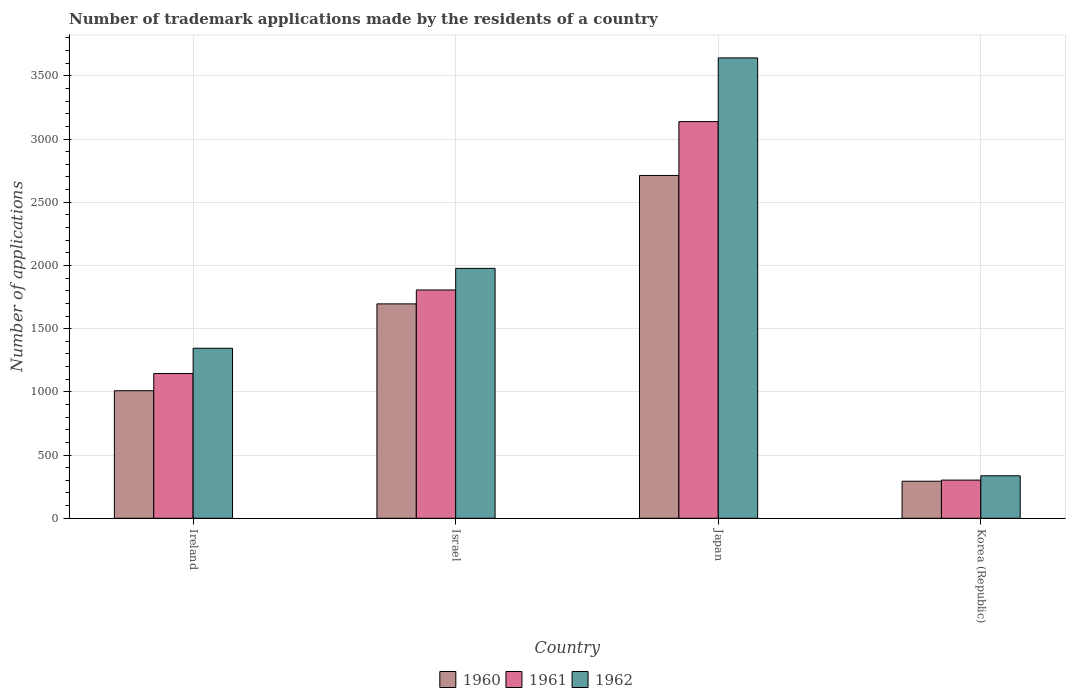How many different coloured bars are there?
Ensure brevity in your answer.  3. How many groups of bars are there?
Keep it short and to the point. 4. Are the number of bars per tick equal to the number of legend labels?
Ensure brevity in your answer.  Yes. What is the label of the 1st group of bars from the left?
Ensure brevity in your answer.  Ireland. What is the number of trademark applications made by the residents in 1960 in Israel?
Your answer should be very brief. 1696. Across all countries, what is the maximum number of trademark applications made by the residents in 1961?
Ensure brevity in your answer.  3138. Across all countries, what is the minimum number of trademark applications made by the residents in 1962?
Your response must be concise. 336. In which country was the number of trademark applications made by the residents in 1962 maximum?
Your response must be concise. Japan. What is the total number of trademark applications made by the residents in 1962 in the graph?
Offer a very short reply. 7300. What is the difference between the number of trademark applications made by the residents in 1961 in Israel and that in Korea (Republic)?
Offer a terse response. 1504. What is the difference between the number of trademark applications made by the residents in 1962 in Israel and the number of trademark applications made by the residents in 1961 in Japan?
Your answer should be very brief. -1161. What is the average number of trademark applications made by the residents in 1962 per country?
Make the answer very short. 1825. What is the difference between the number of trademark applications made by the residents of/in 1961 and number of trademark applications made by the residents of/in 1960 in Israel?
Keep it short and to the point. 110. In how many countries, is the number of trademark applications made by the residents in 1962 greater than 100?
Your answer should be very brief. 4. What is the ratio of the number of trademark applications made by the residents in 1962 in Israel to that in Japan?
Offer a very short reply. 0.54. Is the difference between the number of trademark applications made by the residents in 1961 in Ireland and Israel greater than the difference between the number of trademark applications made by the residents in 1960 in Ireland and Israel?
Give a very brief answer. Yes. What is the difference between the highest and the second highest number of trademark applications made by the residents in 1962?
Make the answer very short. -632. What is the difference between the highest and the lowest number of trademark applications made by the residents in 1961?
Provide a succinct answer. 2836. In how many countries, is the number of trademark applications made by the residents in 1961 greater than the average number of trademark applications made by the residents in 1961 taken over all countries?
Your answer should be compact. 2. Is it the case that in every country, the sum of the number of trademark applications made by the residents in 1962 and number of trademark applications made by the residents in 1961 is greater than the number of trademark applications made by the residents in 1960?
Offer a terse response. Yes. Are all the bars in the graph horizontal?
Your answer should be compact. No. How many countries are there in the graph?
Make the answer very short. 4. What is the difference between two consecutive major ticks on the Y-axis?
Keep it short and to the point. 500. Are the values on the major ticks of Y-axis written in scientific E-notation?
Give a very brief answer. No. How many legend labels are there?
Give a very brief answer. 3. What is the title of the graph?
Your answer should be compact. Number of trademark applications made by the residents of a country. What is the label or title of the X-axis?
Give a very brief answer. Country. What is the label or title of the Y-axis?
Your answer should be very brief. Number of applications. What is the Number of applications in 1960 in Ireland?
Make the answer very short. 1009. What is the Number of applications of 1961 in Ireland?
Keep it short and to the point. 1145. What is the Number of applications in 1962 in Ireland?
Offer a very short reply. 1345. What is the Number of applications in 1960 in Israel?
Provide a succinct answer. 1696. What is the Number of applications in 1961 in Israel?
Ensure brevity in your answer.  1806. What is the Number of applications in 1962 in Israel?
Your answer should be compact. 1977. What is the Number of applications of 1960 in Japan?
Make the answer very short. 2712. What is the Number of applications in 1961 in Japan?
Ensure brevity in your answer.  3138. What is the Number of applications in 1962 in Japan?
Keep it short and to the point. 3642. What is the Number of applications of 1960 in Korea (Republic)?
Offer a terse response. 293. What is the Number of applications in 1961 in Korea (Republic)?
Offer a terse response. 302. What is the Number of applications of 1962 in Korea (Republic)?
Your answer should be very brief. 336. Across all countries, what is the maximum Number of applications of 1960?
Provide a succinct answer. 2712. Across all countries, what is the maximum Number of applications in 1961?
Offer a terse response. 3138. Across all countries, what is the maximum Number of applications in 1962?
Provide a short and direct response. 3642. Across all countries, what is the minimum Number of applications of 1960?
Offer a terse response. 293. Across all countries, what is the minimum Number of applications of 1961?
Offer a terse response. 302. Across all countries, what is the minimum Number of applications in 1962?
Your answer should be compact. 336. What is the total Number of applications of 1960 in the graph?
Your answer should be very brief. 5710. What is the total Number of applications of 1961 in the graph?
Your response must be concise. 6391. What is the total Number of applications in 1962 in the graph?
Your answer should be very brief. 7300. What is the difference between the Number of applications in 1960 in Ireland and that in Israel?
Provide a succinct answer. -687. What is the difference between the Number of applications in 1961 in Ireland and that in Israel?
Your response must be concise. -661. What is the difference between the Number of applications in 1962 in Ireland and that in Israel?
Offer a very short reply. -632. What is the difference between the Number of applications of 1960 in Ireland and that in Japan?
Your answer should be very brief. -1703. What is the difference between the Number of applications in 1961 in Ireland and that in Japan?
Keep it short and to the point. -1993. What is the difference between the Number of applications in 1962 in Ireland and that in Japan?
Your answer should be very brief. -2297. What is the difference between the Number of applications in 1960 in Ireland and that in Korea (Republic)?
Give a very brief answer. 716. What is the difference between the Number of applications in 1961 in Ireland and that in Korea (Republic)?
Give a very brief answer. 843. What is the difference between the Number of applications of 1962 in Ireland and that in Korea (Republic)?
Ensure brevity in your answer.  1009. What is the difference between the Number of applications of 1960 in Israel and that in Japan?
Make the answer very short. -1016. What is the difference between the Number of applications in 1961 in Israel and that in Japan?
Provide a succinct answer. -1332. What is the difference between the Number of applications in 1962 in Israel and that in Japan?
Offer a terse response. -1665. What is the difference between the Number of applications of 1960 in Israel and that in Korea (Republic)?
Your answer should be compact. 1403. What is the difference between the Number of applications of 1961 in Israel and that in Korea (Republic)?
Your response must be concise. 1504. What is the difference between the Number of applications in 1962 in Israel and that in Korea (Republic)?
Your answer should be compact. 1641. What is the difference between the Number of applications of 1960 in Japan and that in Korea (Republic)?
Provide a succinct answer. 2419. What is the difference between the Number of applications of 1961 in Japan and that in Korea (Republic)?
Provide a short and direct response. 2836. What is the difference between the Number of applications of 1962 in Japan and that in Korea (Republic)?
Make the answer very short. 3306. What is the difference between the Number of applications of 1960 in Ireland and the Number of applications of 1961 in Israel?
Your response must be concise. -797. What is the difference between the Number of applications in 1960 in Ireland and the Number of applications in 1962 in Israel?
Your answer should be very brief. -968. What is the difference between the Number of applications in 1961 in Ireland and the Number of applications in 1962 in Israel?
Your answer should be compact. -832. What is the difference between the Number of applications of 1960 in Ireland and the Number of applications of 1961 in Japan?
Give a very brief answer. -2129. What is the difference between the Number of applications in 1960 in Ireland and the Number of applications in 1962 in Japan?
Make the answer very short. -2633. What is the difference between the Number of applications of 1961 in Ireland and the Number of applications of 1962 in Japan?
Offer a terse response. -2497. What is the difference between the Number of applications of 1960 in Ireland and the Number of applications of 1961 in Korea (Republic)?
Keep it short and to the point. 707. What is the difference between the Number of applications of 1960 in Ireland and the Number of applications of 1962 in Korea (Republic)?
Your response must be concise. 673. What is the difference between the Number of applications of 1961 in Ireland and the Number of applications of 1962 in Korea (Republic)?
Your answer should be compact. 809. What is the difference between the Number of applications in 1960 in Israel and the Number of applications in 1961 in Japan?
Provide a short and direct response. -1442. What is the difference between the Number of applications in 1960 in Israel and the Number of applications in 1962 in Japan?
Provide a succinct answer. -1946. What is the difference between the Number of applications of 1961 in Israel and the Number of applications of 1962 in Japan?
Ensure brevity in your answer.  -1836. What is the difference between the Number of applications in 1960 in Israel and the Number of applications in 1961 in Korea (Republic)?
Ensure brevity in your answer.  1394. What is the difference between the Number of applications in 1960 in Israel and the Number of applications in 1962 in Korea (Republic)?
Your answer should be very brief. 1360. What is the difference between the Number of applications of 1961 in Israel and the Number of applications of 1962 in Korea (Republic)?
Your answer should be compact. 1470. What is the difference between the Number of applications of 1960 in Japan and the Number of applications of 1961 in Korea (Republic)?
Keep it short and to the point. 2410. What is the difference between the Number of applications of 1960 in Japan and the Number of applications of 1962 in Korea (Republic)?
Provide a short and direct response. 2376. What is the difference between the Number of applications of 1961 in Japan and the Number of applications of 1962 in Korea (Republic)?
Your answer should be very brief. 2802. What is the average Number of applications of 1960 per country?
Provide a succinct answer. 1427.5. What is the average Number of applications of 1961 per country?
Offer a terse response. 1597.75. What is the average Number of applications in 1962 per country?
Give a very brief answer. 1825. What is the difference between the Number of applications of 1960 and Number of applications of 1961 in Ireland?
Provide a succinct answer. -136. What is the difference between the Number of applications of 1960 and Number of applications of 1962 in Ireland?
Your answer should be very brief. -336. What is the difference between the Number of applications of 1961 and Number of applications of 1962 in Ireland?
Provide a succinct answer. -200. What is the difference between the Number of applications in 1960 and Number of applications in 1961 in Israel?
Offer a very short reply. -110. What is the difference between the Number of applications of 1960 and Number of applications of 1962 in Israel?
Offer a very short reply. -281. What is the difference between the Number of applications of 1961 and Number of applications of 1962 in Israel?
Your answer should be very brief. -171. What is the difference between the Number of applications in 1960 and Number of applications in 1961 in Japan?
Keep it short and to the point. -426. What is the difference between the Number of applications in 1960 and Number of applications in 1962 in Japan?
Give a very brief answer. -930. What is the difference between the Number of applications of 1961 and Number of applications of 1962 in Japan?
Offer a terse response. -504. What is the difference between the Number of applications of 1960 and Number of applications of 1962 in Korea (Republic)?
Make the answer very short. -43. What is the difference between the Number of applications in 1961 and Number of applications in 1962 in Korea (Republic)?
Your answer should be compact. -34. What is the ratio of the Number of applications of 1960 in Ireland to that in Israel?
Offer a very short reply. 0.59. What is the ratio of the Number of applications of 1961 in Ireland to that in Israel?
Your response must be concise. 0.63. What is the ratio of the Number of applications in 1962 in Ireland to that in Israel?
Provide a succinct answer. 0.68. What is the ratio of the Number of applications in 1960 in Ireland to that in Japan?
Your answer should be very brief. 0.37. What is the ratio of the Number of applications in 1961 in Ireland to that in Japan?
Offer a terse response. 0.36. What is the ratio of the Number of applications of 1962 in Ireland to that in Japan?
Your answer should be very brief. 0.37. What is the ratio of the Number of applications of 1960 in Ireland to that in Korea (Republic)?
Offer a terse response. 3.44. What is the ratio of the Number of applications of 1961 in Ireland to that in Korea (Republic)?
Your answer should be compact. 3.79. What is the ratio of the Number of applications of 1962 in Ireland to that in Korea (Republic)?
Provide a succinct answer. 4. What is the ratio of the Number of applications in 1960 in Israel to that in Japan?
Give a very brief answer. 0.63. What is the ratio of the Number of applications in 1961 in Israel to that in Japan?
Make the answer very short. 0.58. What is the ratio of the Number of applications in 1962 in Israel to that in Japan?
Give a very brief answer. 0.54. What is the ratio of the Number of applications in 1960 in Israel to that in Korea (Republic)?
Provide a succinct answer. 5.79. What is the ratio of the Number of applications of 1961 in Israel to that in Korea (Republic)?
Provide a short and direct response. 5.98. What is the ratio of the Number of applications in 1962 in Israel to that in Korea (Republic)?
Provide a succinct answer. 5.88. What is the ratio of the Number of applications in 1960 in Japan to that in Korea (Republic)?
Make the answer very short. 9.26. What is the ratio of the Number of applications of 1961 in Japan to that in Korea (Republic)?
Offer a very short reply. 10.39. What is the ratio of the Number of applications in 1962 in Japan to that in Korea (Republic)?
Your answer should be compact. 10.84. What is the difference between the highest and the second highest Number of applications of 1960?
Provide a succinct answer. 1016. What is the difference between the highest and the second highest Number of applications in 1961?
Provide a short and direct response. 1332. What is the difference between the highest and the second highest Number of applications in 1962?
Offer a terse response. 1665. What is the difference between the highest and the lowest Number of applications in 1960?
Offer a very short reply. 2419. What is the difference between the highest and the lowest Number of applications of 1961?
Offer a terse response. 2836. What is the difference between the highest and the lowest Number of applications in 1962?
Make the answer very short. 3306. 